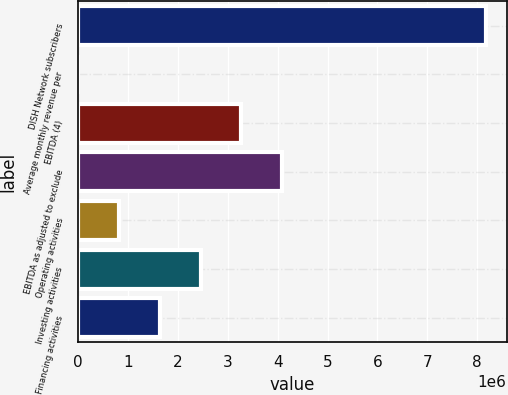<chart> <loc_0><loc_0><loc_500><loc_500><bar_chart><fcel>DISH Network subscribers<fcel>Average monthly revenue per<fcel>EBITDA (4)<fcel>EBITDA as adjusted to exclude<fcel>Operating activities<fcel>Investing activities<fcel>Financing activities<nl><fcel>8.18e+06<fcel>49.17<fcel>3.27203e+06<fcel>4.09002e+06<fcel>818044<fcel>2.45403e+06<fcel>1.63604e+06<nl></chart> 